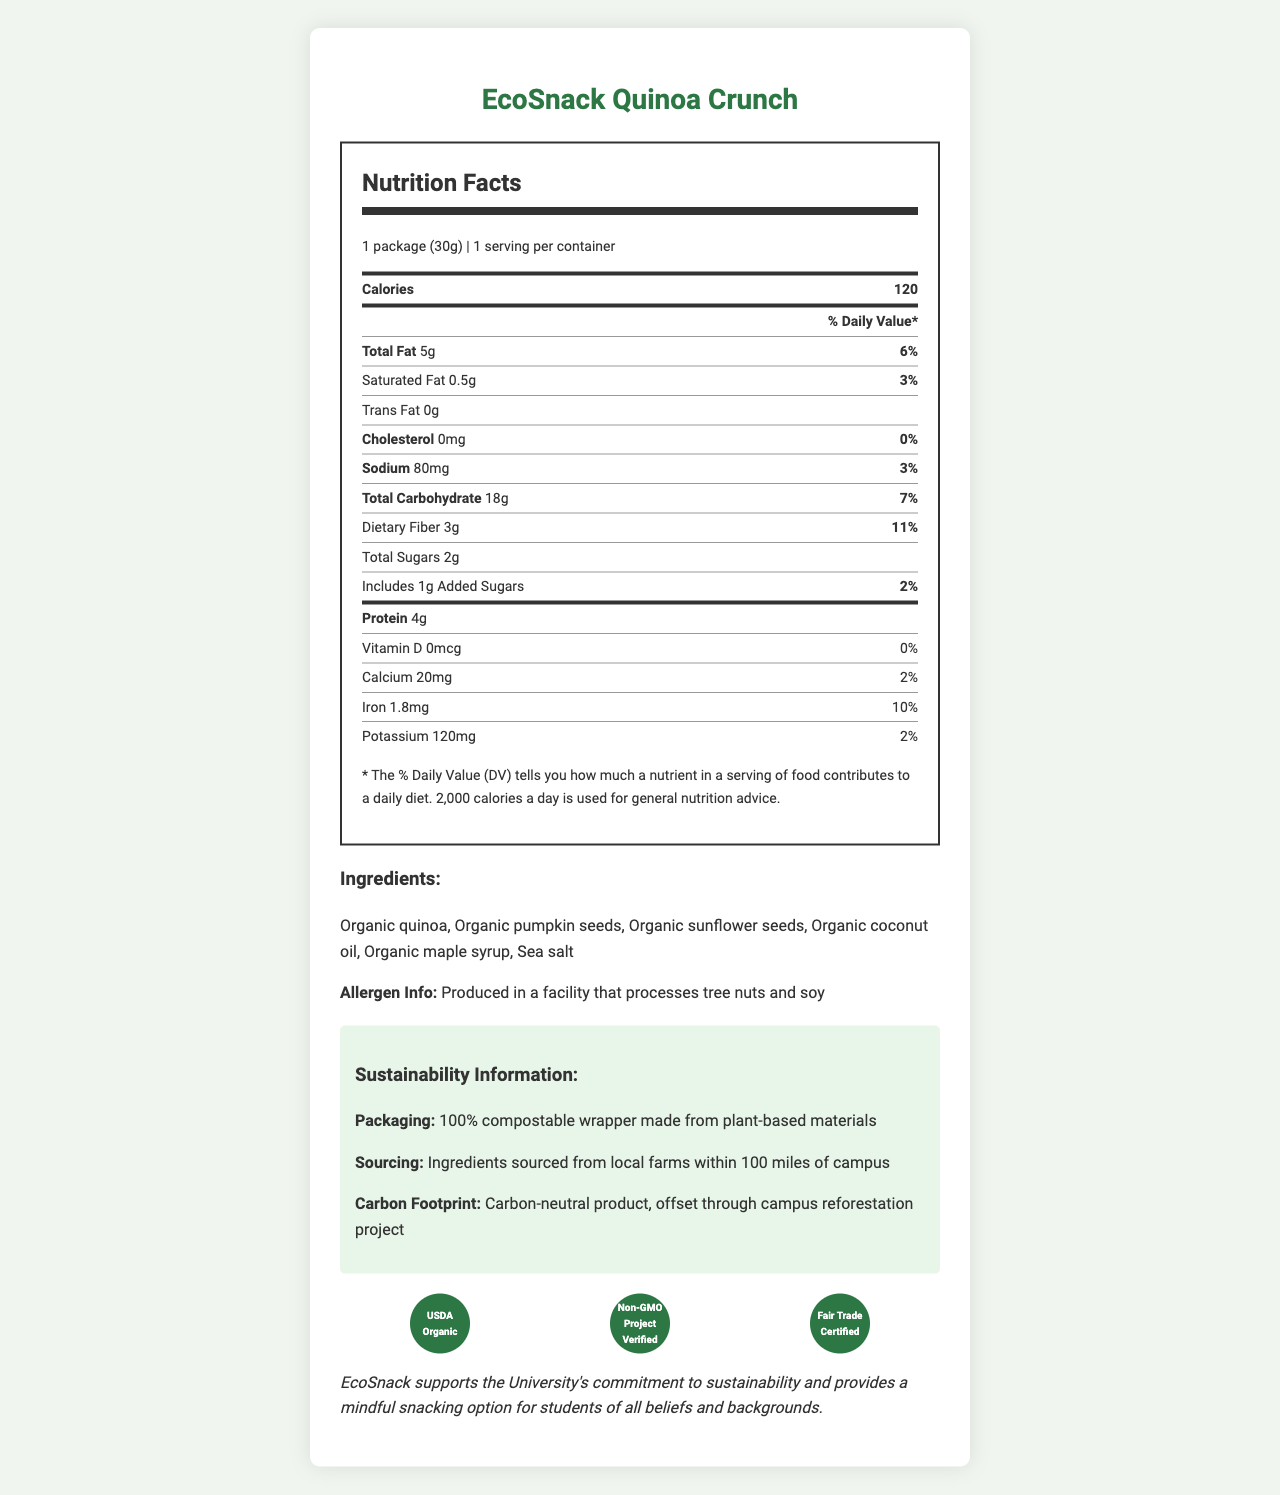What is the serving size of EcoSnack Quinoa Crunch? The document states that the serving size is "1 package (30g)".
Answer: 1 package (30g) How many calories are in one serving of EcoSnack Quinoa Crunch? The document lists the calories per serving as 120.
Answer: 120 Which certification does EcoSnack Quinoa Crunch hold? A. USDA Organic B. Fair Trade Certified C. Non-GMO Project Verified D. All of the above The document states that the certifications include USDA Organic, Non-GMO Project Verified, and Fair Trade Certified.
Answer: D What ingredients are used in EcoSnack Quinoa Crunch? The ingredients list provided in the document includes these items.
Answer: Organic quinoa, Organic pumpkin seeds, Organic sunflower seeds, Organic coconut oil, Organic maple syrup, Sea salt What is the total fat content and its daily value percentage? The document states the total fat is 5g, which is 6% of the daily value.
Answer: 5g, 6% Does EcoSnack Quinoa Crunch contain any trans fats? The document specifies that the trans fat content is 0g.
Answer: No What percentage of the daily value for dietary fiber does EcoSnack Quinoa Crunch provide? The document lists the daily value percentage for dietary fiber as 11%.
Answer: 11% What is the sodium content in one package of EcoSnack Quinoa Crunch? A. 40mg B. 80mg C. 100mg D. 120mg The sodium content is listed as 80mg in the document.
Answer: B Is the packaging of EcoSnack Quinoa Crunch compostable? The document specifies that the packaging is 100% compostable, made from plant-based materials.
Answer: Yes Does EcoSnack Quinoa Crunch contain any added sugars? The document lists 1g of added sugars.
Answer: Yes Summarize the sustainability information provided in the document. The document details the sustainability initiatives related to packaging, sourcing, and carbon footprint to highlight the product's environmental benefits.
Answer: The sustainability information indicates that EcoSnack Quinoa Crunch has 100% compostable packaging made from plant-based materials, the ingredients are sourced locally from farms within 100 miles of campus, and it is a carbon-neutral product offset through a campus reforestation project. Was the EcoSnack Quinoa Crunch produced in a facility that handles soy? The allergen info section states that it was produced in a facility that processes tree nuts and soy.
Answer: Yes How much protein is in one serving of EcoSnack Quinoa Crunch? The document states that each serving contains 4g of protein.
Answer: 4g Does the vitamin D content in EcoSnack Quinoa Crunch contribute to the daily value percentage? The document lists the vitamin D content as 0mcg with a 0% daily value.
Answer: No What is the brand statement of EcoSnack Quinoa Crunch? The document includes this as the brand statement.
Answer: "EcoSnack supports the University's commitment to sustainability and provides a mindful snacking option for students of all beliefs and backgrounds." What is the source location of the ingredients used in EcoSnack Quinoa Crunch? Although the document states that ingredients are sourced from local farms within 100 miles of campus, it does not specify the exact location or name of the farms.
Answer: Not enough information 